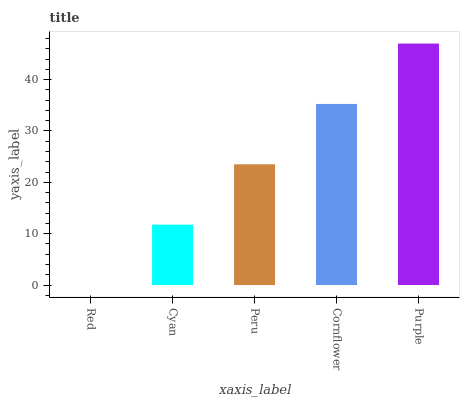Is Red the minimum?
Answer yes or no. Yes. Is Purple the maximum?
Answer yes or no. Yes. Is Cyan the minimum?
Answer yes or no. No. Is Cyan the maximum?
Answer yes or no. No. Is Cyan greater than Red?
Answer yes or no. Yes. Is Red less than Cyan?
Answer yes or no. Yes. Is Red greater than Cyan?
Answer yes or no. No. Is Cyan less than Red?
Answer yes or no. No. Is Peru the high median?
Answer yes or no. Yes. Is Peru the low median?
Answer yes or no. Yes. Is Cyan the high median?
Answer yes or no. No. Is Purple the low median?
Answer yes or no. No. 